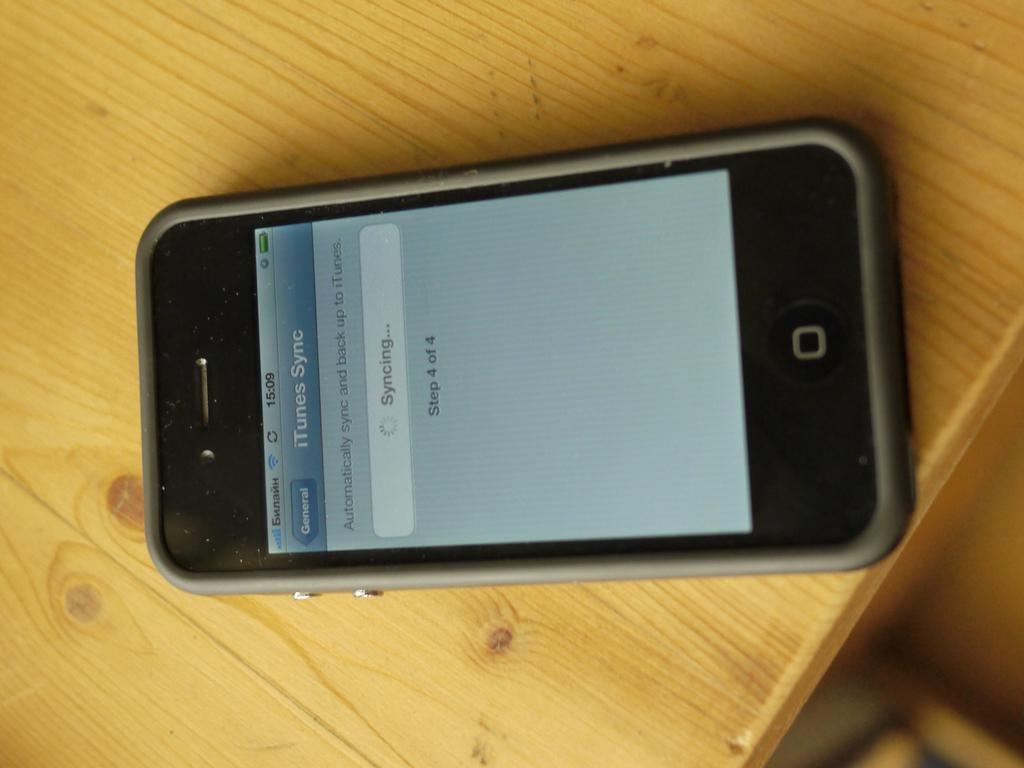<image>
Present a compact description of the photo's key features. An older generation iPhone is on a wooden table and says Syncing. 